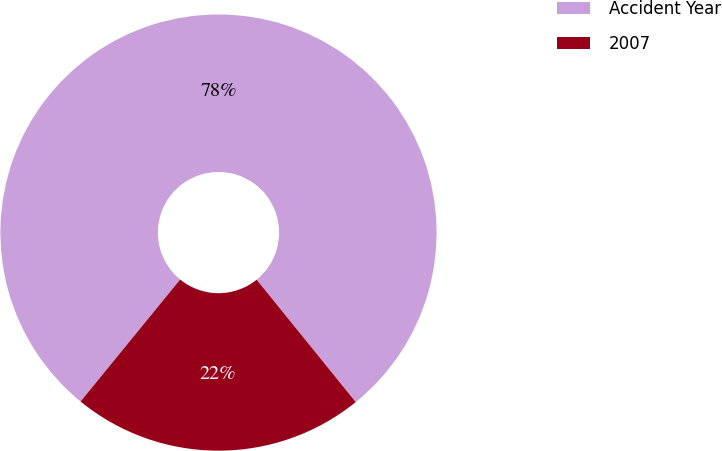Convert chart. <chart><loc_0><loc_0><loc_500><loc_500><pie_chart><fcel>Accident Year<fcel>2007<nl><fcel>78.27%<fcel>21.73%<nl></chart> 